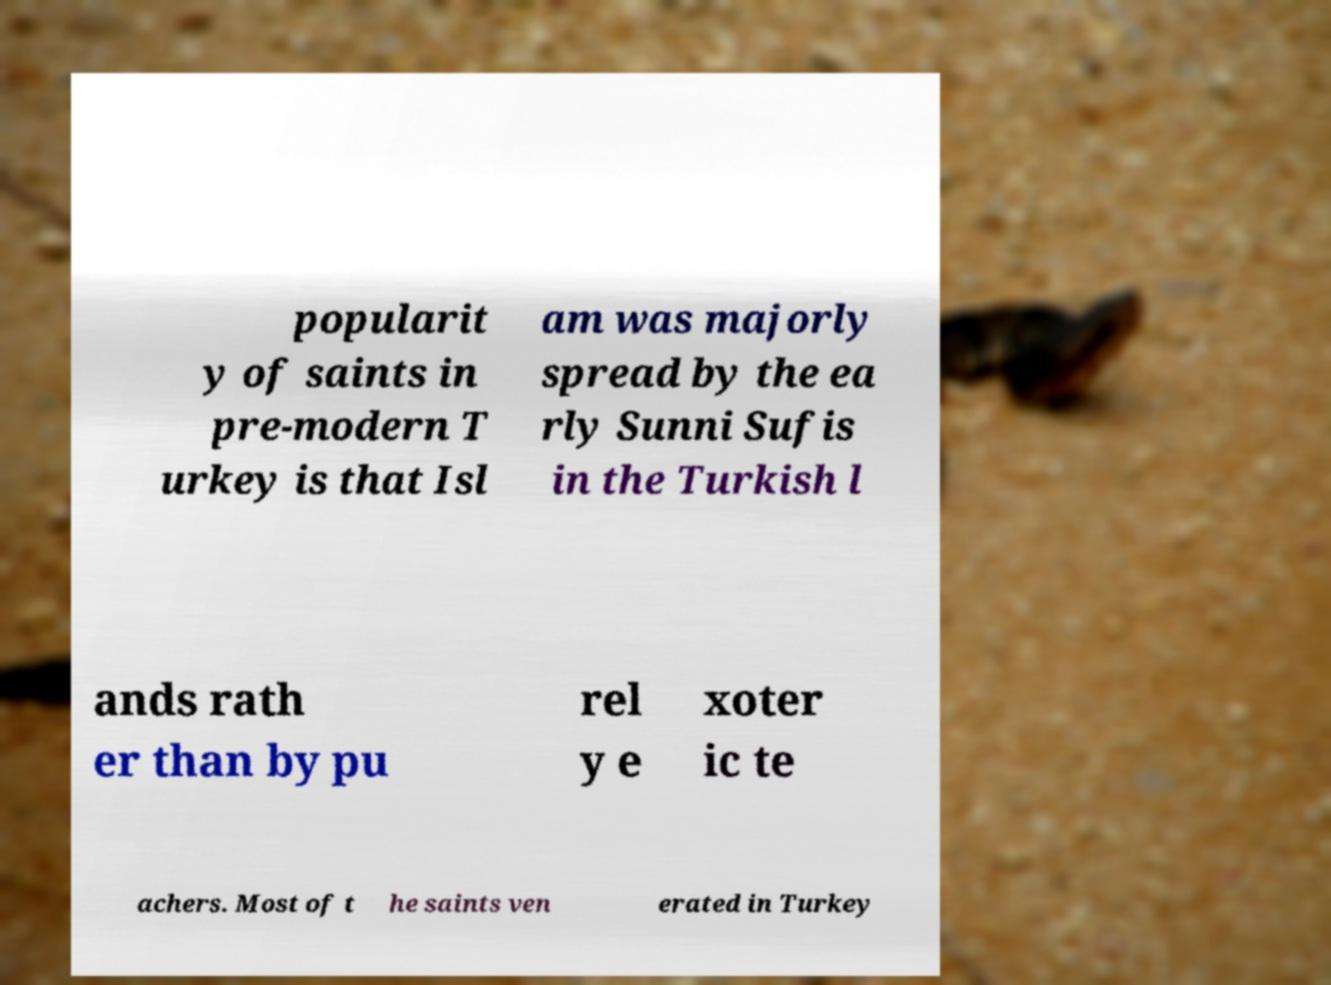I need the written content from this picture converted into text. Can you do that? popularit y of saints in pre-modern T urkey is that Isl am was majorly spread by the ea rly Sunni Sufis in the Turkish l ands rath er than by pu rel y e xoter ic te achers. Most of t he saints ven erated in Turkey 